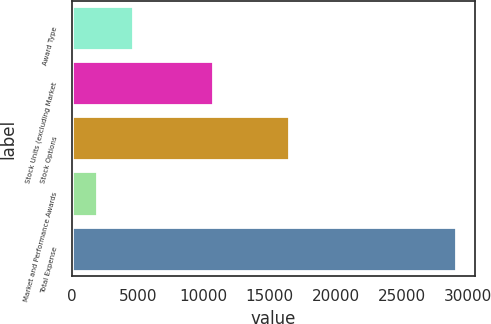<chart> <loc_0><loc_0><loc_500><loc_500><bar_chart><fcel>Award Type<fcel>Stock Units (excluding Market<fcel>Stock Options<fcel>Market and Performance Awards<fcel>Total Expense<nl><fcel>4623.8<fcel>10710<fcel>16468<fcel>1906<fcel>29084<nl></chart> 